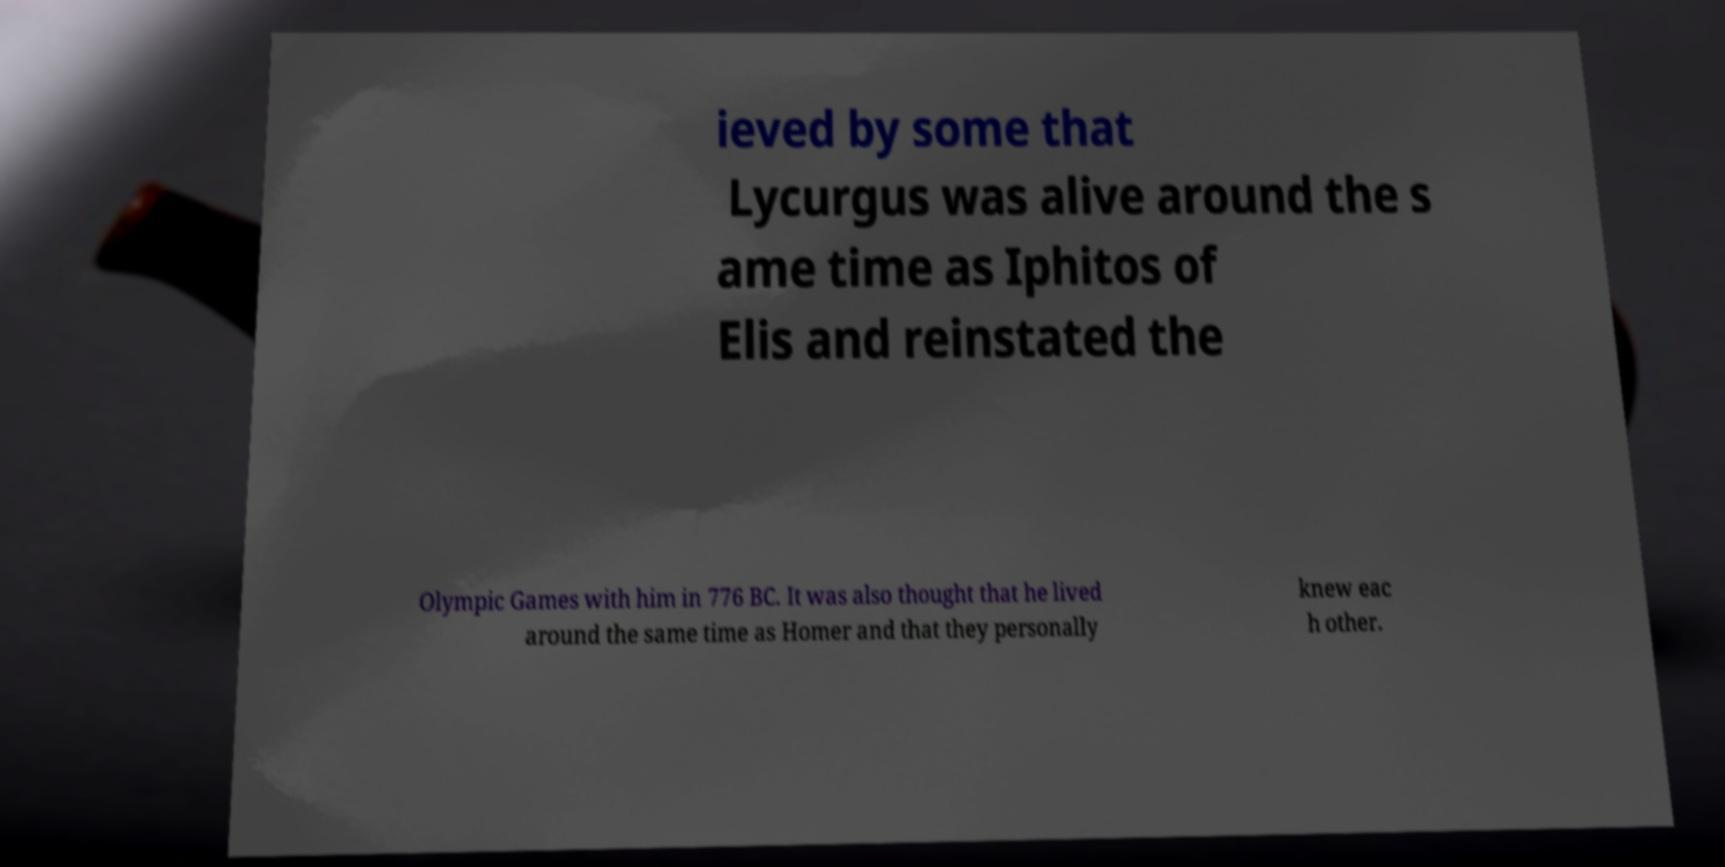What messages or text are displayed in this image? I need them in a readable, typed format. ieved by some that Lycurgus was alive around the s ame time as Iphitos of Elis and reinstated the Olympic Games with him in 776 BC. It was also thought that he lived around the same time as Homer and that they personally knew eac h other. 